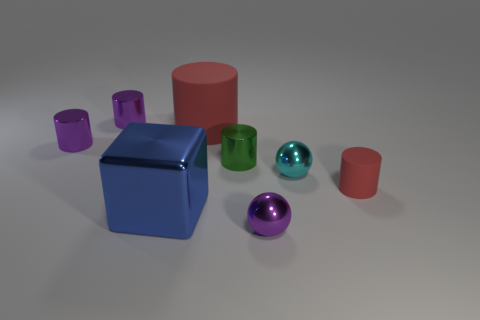There is a tiny cylinder that is behind the small purple metal cylinder in front of the large cylinder; what is it made of?
Offer a very short reply. Metal. What number of things are either big cyan metallic cylinders or metallic things that are behind the big blue cube?
Your response must be concise. 4. The cyan sphere that is made of the same material as the small green thing is what size?
Provide a short and direct response. Small. What number of blue things are either large things or metallic objects?
Give a very brief answer. 1. Is there anything else that has the same material as the cube?
Ensure brevity in your answer.  Yes. There is a tiny purple metal object that is to the right of the green metallic thing; does it have the same shape as the red thing behind the green cylinder?
Provide a succinct answer. No. How many tiny purple cylinders are there?
Offer a very short reply. 2. What is the shape of the large object that is the same material as the cyan ball?
Your answer should be very brief. Cube. Is there any other thing that has the same color as the metal block?
Ensure brevity in your answer.  No. There is a metallic block; is it the same color as the cylinder that is in front of the green cylinder?
Offer a terse response. No. 